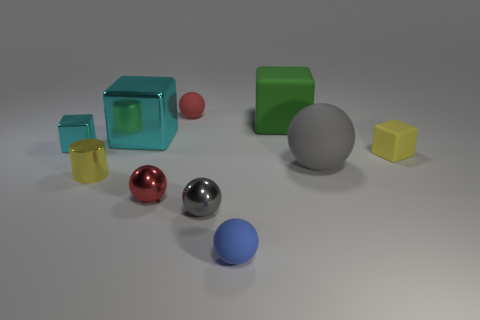Do the metal cylinder and the big ball have the same color?
Offer a very short reply. No. Does the ball behind the green rubber block have the same material as the big thing that is in front of the tiny cyan object?
Offer a terse response. Yes. What number of other things are the same size as the yellow matte cube?
Your response must be concise. 6. How many things are green metal things or rubber objects that are behind the tiny cyan metallic block?
Give a very brief answer. 2. Are there the same number of tiny yellow cubes that are in front of the tiny yellow cube and large matte spheres?
Your answer should be compact. No. The small red thing that is the same material as the large gray thing is what shape?
Provide a succinct answer. Sphere. Are there any objects of the same color as the big rubber block?
Provide a short and direct response. No. What number of metallic objects are either big cyan objects or red objects?
Provide a succinct answer. 2. There is a yellow thing that is on the left side of the red rubber object; what number of shiny balls are on the left side of it?
Your answer should be very brief. 0. What number of cylinders have the same material as the green cube?
Give a very brief answer. 0. 